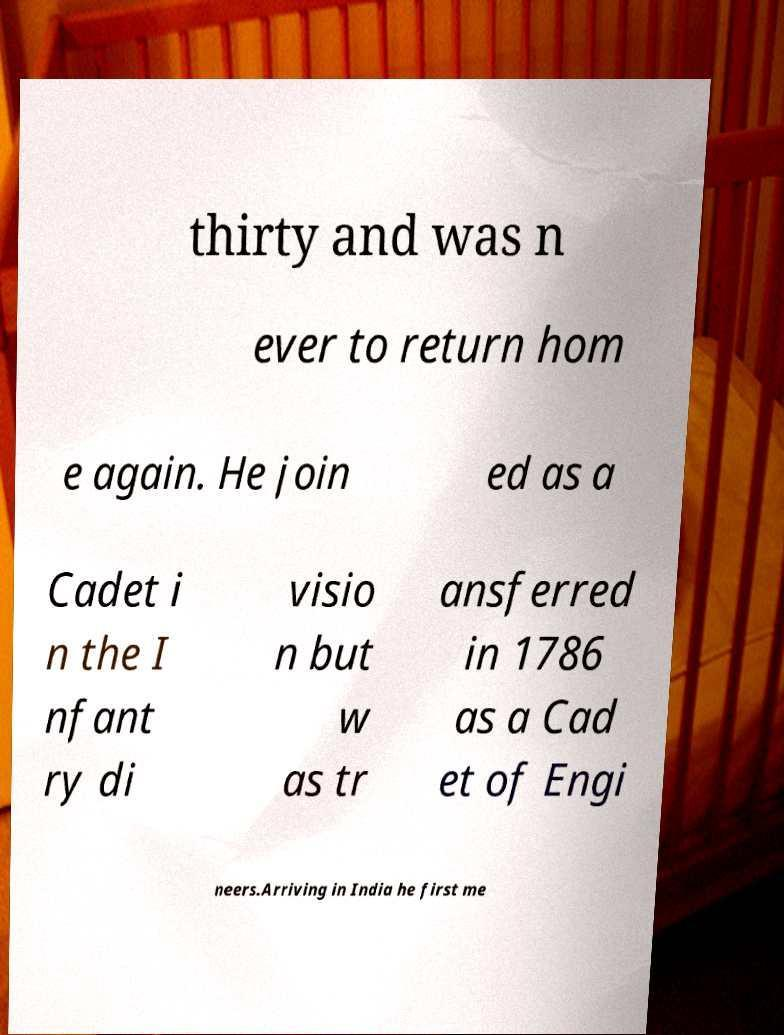There's text embedded in this image that I need extracted. Can you transcribe it verbatim? thirty and was n ever to return hom e again. He join ed as a Cadet i n the I nfant ry di visio n but w as tr ansferred in 1786 as a Cad et of Engi neers.Arriving in India he first me 